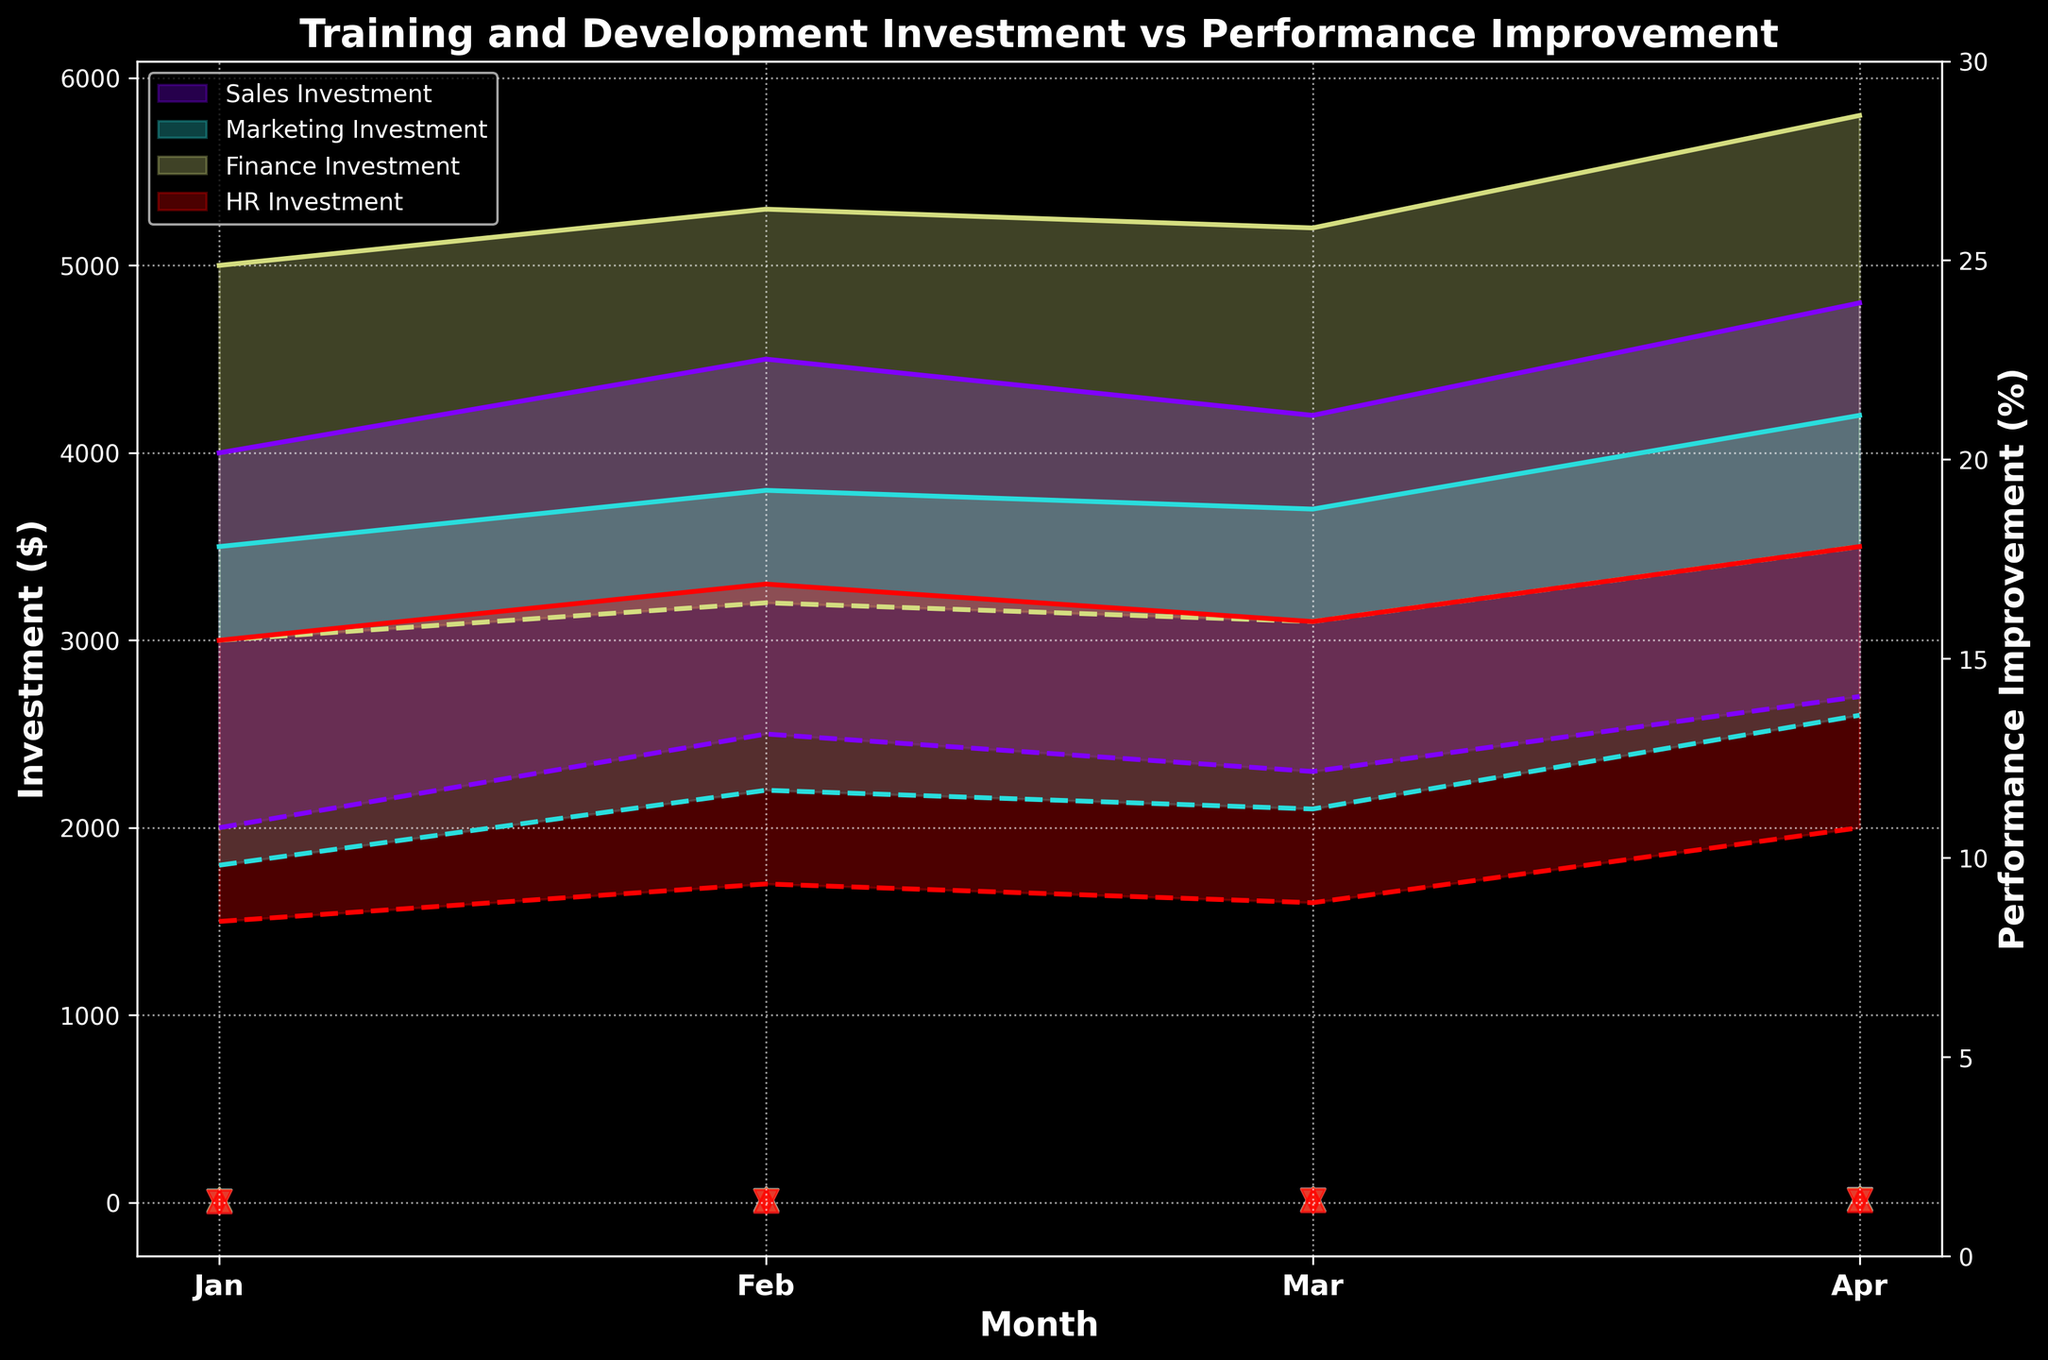What is the title of the figure? The title of the figure is usually displayed at the top of the plot. By reading the text at the top, we can determine the exact title.
Answer: Training and Development Investment vs Performance Improvement What are the minimum and maximum performance improvements for the Finance team in February? To find this, look for the February data points for the Finance team. The vertical position of the triangle markers (pointing down for min and up for max) indicates the performance improvements.
Answer: 10%, 20% Which team had the highest maximum investment in April? Look for the highest point on the y-axis in April marked by the filled color bands. This shows the maximum range of investment for each team.
Answer: Finance Compare the range of investments between the Sales and Marketing teams in January. Which team has a wider investment range? Calculate investment ranges (Max Investment - Min Investment) for both teams in January. Sales: 4000 - 2000 = 2000. Marketing: 3500 - 1800 = 1700.
Answer: Sales What is the general trend in performance improvement for HR from January to April? Observe the markers representing HR across the months. Trace the path of how these markers change from January to April. Identify increases or decreases.
Answer: Increasing Between which two months did the Marketing team see the highest improvement in their minimum performance improvement? Compare the minimum performance improvement values (indicated by the downward triangles) for the Marketing team month by month. Calculate the differences between consecutive months.
Answer: January to February What is the average maximum investment for the Sales team over the four months? Add up the maximum investment values for Sales team across all months and divide by 4. \( (4000 + 4500 + 4200 + 4800) / 4 = 4375 \)
Answer: 4375 Which team had the lowest maximum performance improvement in January? Compare the highest positions of the upward triangles for all teams in January. The lowest one represents the lowest maximum performance improvement.
Answer: HR Is there any team that shows a consistent increase in both investment and performance improvement from January to April? If so, which team(s)? For each team, observe the paths of both the investment bands and performance markers over the months. Identify if there is a consistent upward trend in both measures from January to April.
Answer: Sales, Finance How do the ranges of investment in April compare between Finance and HR teams? Compare the vertical distance between the max and min boundaries of the filled area for both teams in April. Calculate the investment ranges: 
Finance: \(5800 - 3500 = 2300\) 
HR: \(3500 - 2000 = 1500\)
Answer: Finance has a wider range 